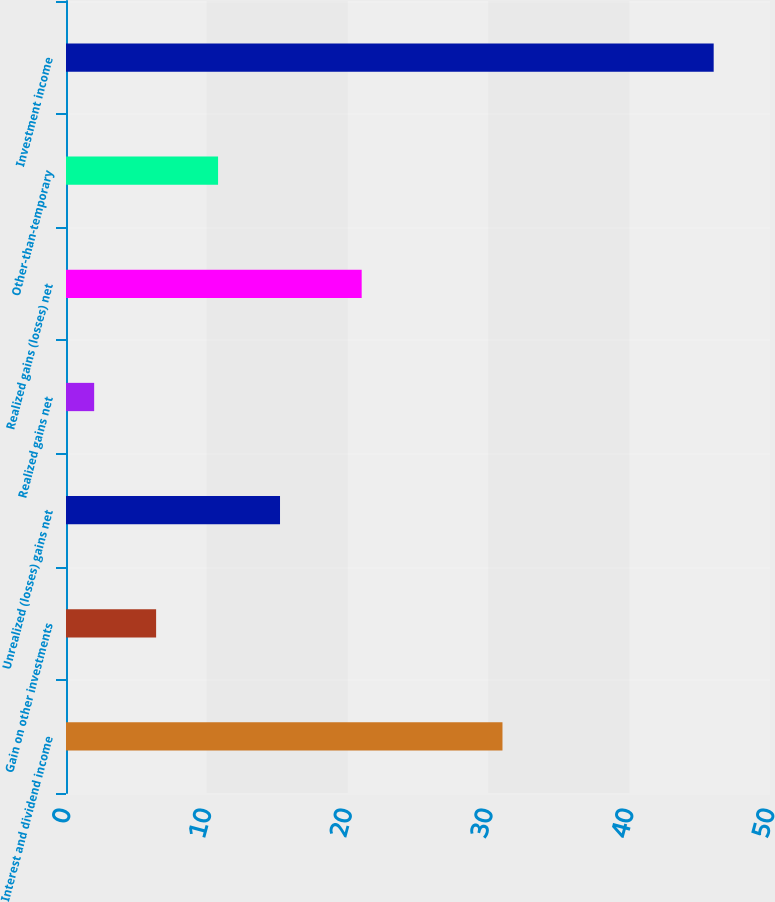<chart> <loc_0><loc_0><loc_500><loc_500><bar_chart><fcel>Interest and dividend income<fcel>Gain on other investments<fcel>Unrealized (losses) gains net<fcel>Realized gains net<fcel>Realized gains (losses) net<fcel>Other-than-temporary<fcel>Investment income<nl><fcel>31<fcel>6.4<fcel>15.2<fcel>2<fcel>21<fcel>10.8<fcel>46<nl></chart> 